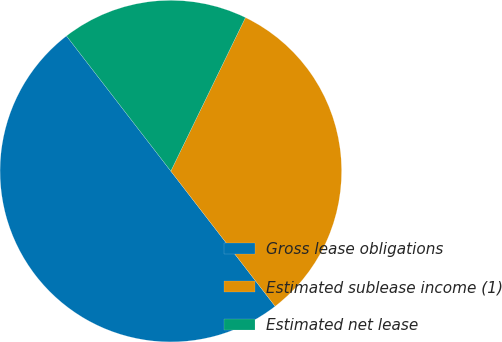Convert chart. <chart><loc_0><loc_0><loc_500><loc_500><pie_chart><fcel>Gross lease obligations<fcel>Estimated sublease income (1)<fcel>Estimated net lease<nl><fcel>50.0%<fcel>32.34%<fcel>17.66%<nl></chart> 